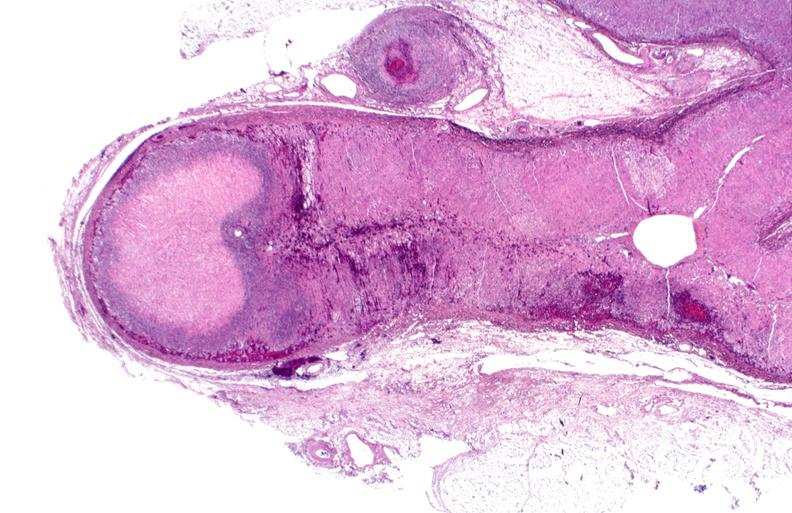what does this image show?
Answer the question using a single word or phrase. Adrenal 